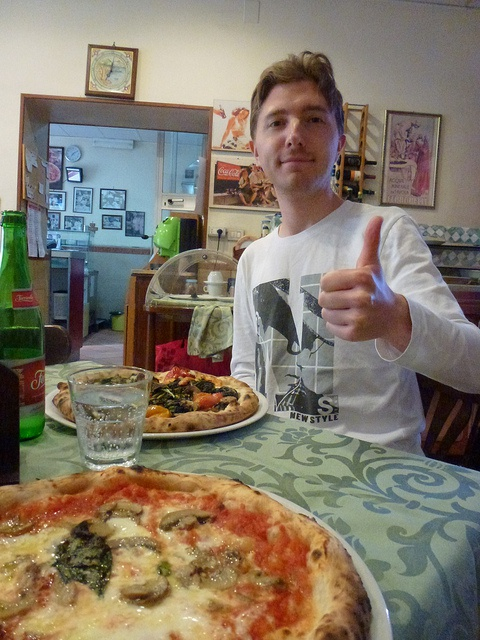Describe the objects in this image and their specific colors. I can see dining table in darkgray, tan, brown, and gray tones, people in darkgray, gray, and lightgray tones, pizza in darkgray, brown, tan, and olive tones, pizza in darkgray, tan, gray, and olive tones, and bottle in darkgray, darkgreen, black, and maroon tones in this image. 